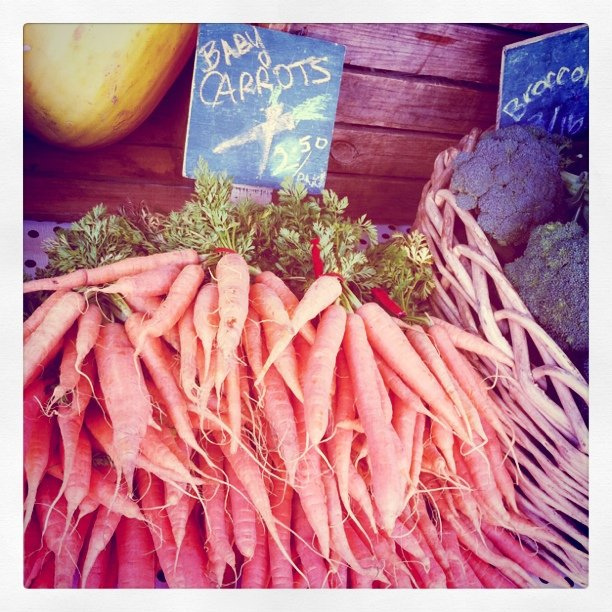Is this area in a market? Yes, the presence of price tags and the display of vegetables on a wooden table suggests these carrots are being sold at a market. 